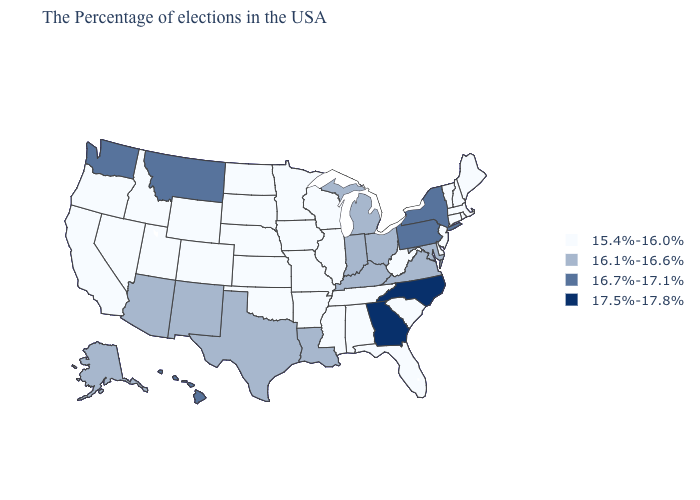What is the value of Illinois?
Short answer required. 15.4%-16.0%. What is the value of Louisiana?
Keep it brief. 16.1%-16.6%. Name the states that have a value in the range 17.5%-17.8%?
Give a very brief answer. North Carolina, Georgia. What is the lowest value in the USA?
Keep it brief. 15.4%-16.0%. Name the states that have a value in the range 16.7%-17.1%?
Quick response, please. New York, Pennsylvania, Montana, Washington, Hawaii. Does Nebraska have the highest value in the MidWest?
Write a very short answer. No. What is the value of Washington?
Answer briefly. 16.7%-17.1%. Does Pennsylvania have the lowest value in the USA?
Write a very short answer. No. What is the value of Rhode Island?
Short answer required. 15.4%-16.0%. Is the legend a continuous bar?
Keep it brief. No. What is the value of Nebraska?
Keep it brief. 15.4%-16.0%. What is the lowest value in the Northeast?
Concise answer only. 15.4%-16.0%. What is the lowest value in the West?
Answer briefly. 15.4%-16.0%. Name the states that have a value in the range 17.5%-17.8%?
Quick response, please. North Carolina, Georgia. What is the value of Arkansas?
Keep it brief. 15.4%-16.0%. 